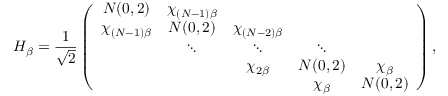<formula> <loc_0><loc_0><loc_500><loc_500>H _ { \beta } = \frac { 1 } { \sqrt { 2 } } \left ( \begin{array} { c c c c c } { N ( 0 , 2 ) } & { \chi _ { ( N - 1 ) \beta } } & & & \\ { \chi _ { ( N - 1 ) \beta } } & { N ( 0 , 2 ) } & { \chi _ { ( N - 2 ) \beta } } & & \\ & { \ddots } & { \ddots } & { \ddots } & \\ & & { \chi _ { 2 \beta } } & { N ( 0 , 2 ) } & { \chi _ { \beta } } \\ & & & { \chi _ { \beta } } & { N ( 0 , 2 ) } \end{array} \right ) ,</formula> 